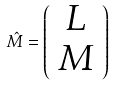<formula> <loc_0><loc_0><loc_500><loc_500>\hat { M } = \left ( \begin{array} { c } { L } \\ { M } \end{array} \right )</formula> 